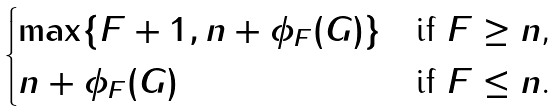<formula> <loc_0><loc_0><loc_500><loc_500>\begin{cases} \max \{ \| F \| + 1 , n + \phi _ { F } ( G ) \} & \text {if $\| F \| \geq n$,} \\ n + \phi _ { F } ( G ) & \text {if $\| F \| \leq n$.} \\ \end{cases}</formula> 